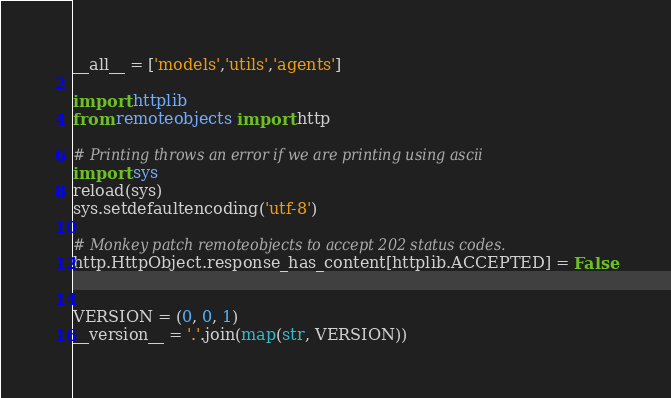Convert code to text. <code><loc_0><loc_0><loc_500><loc_500><_Python_>__all__ = ['models','utils','agents']

import httplib
from remoteobjects import http

# Printing throws an error if we are printing using ascii
import sys
reload(sys)
sys.setdefaultencoding('utf-8')

# Monkey patch remoteobjects to accept 202 status codes.
http.HttpObject.response_has_content[httplib.ACCEPTED] = False


VERSION = (0, 0, 1)
__version__ = '.'.join(map(str, VERSION))
</code> 